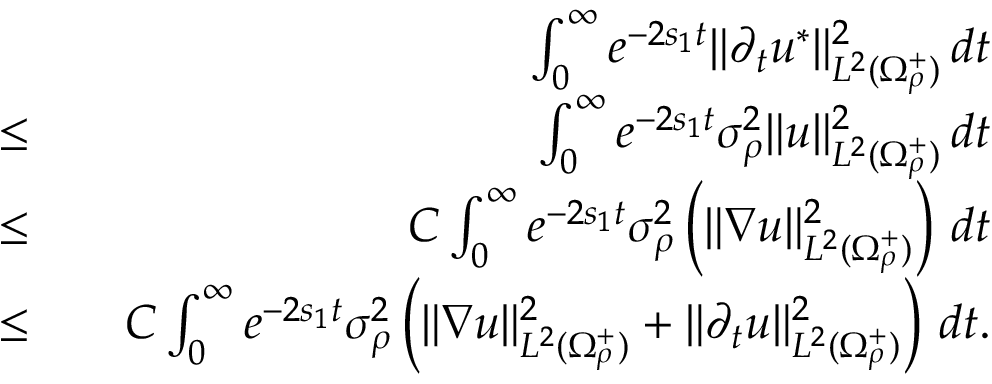Convert formula to latex. <formula><loc_0><loc_0><loc_500><loc_500>\begin{array} { r l r } & { \int _ { 0 } ^ { \infty } e ^ { - 2 s _ { 1 } t } \| \partial _ { t } u ^ { * } \| _ { L ^ { 2 } ( \Omega _ { \rho } ^ { + } ) } ^ { 2 } \, d t } \\ { \leq } & { \int _ { 0 } ^ { \infty } e ^ { - 2 s _ { 1 } t } \sigma _ { \rho } ^ { 2 } \| u \| _ { L ^ { 2 } ( \Omega _ { \rho } ^ { + } ) } ^ { 2 } \, d t } \\ { \leq } & { C \int _ { 0 } ^ { \infty } e ^ { - 2 s _ { 1 } t } \sigma _ { \rho } ^ { 2 } \left ( \| \nabla u \| _ { L ^ { 2 } ( \Omega _ { \rho } ^ { + } ) } ^ { 2 } \right ) \, d t } \\ { \leq } & { C \int _ { 0 } ^ { \infty } e ^ { - 2 s _ { 1 } t } \sigma _ { \rho } ^ { 2 } \left ( \| \nabla u \| _ { L ^ { 2 } ( \Omega _ { \rho } ^ { + } ) } ^ { 2 } + \| \partial _ { t } u \| _ { L ^ { 2 } ( \Omega _ { \rho } ^ { + } ) } ^ { 2 } \right ) \, d t . } \end{array}</formula> 